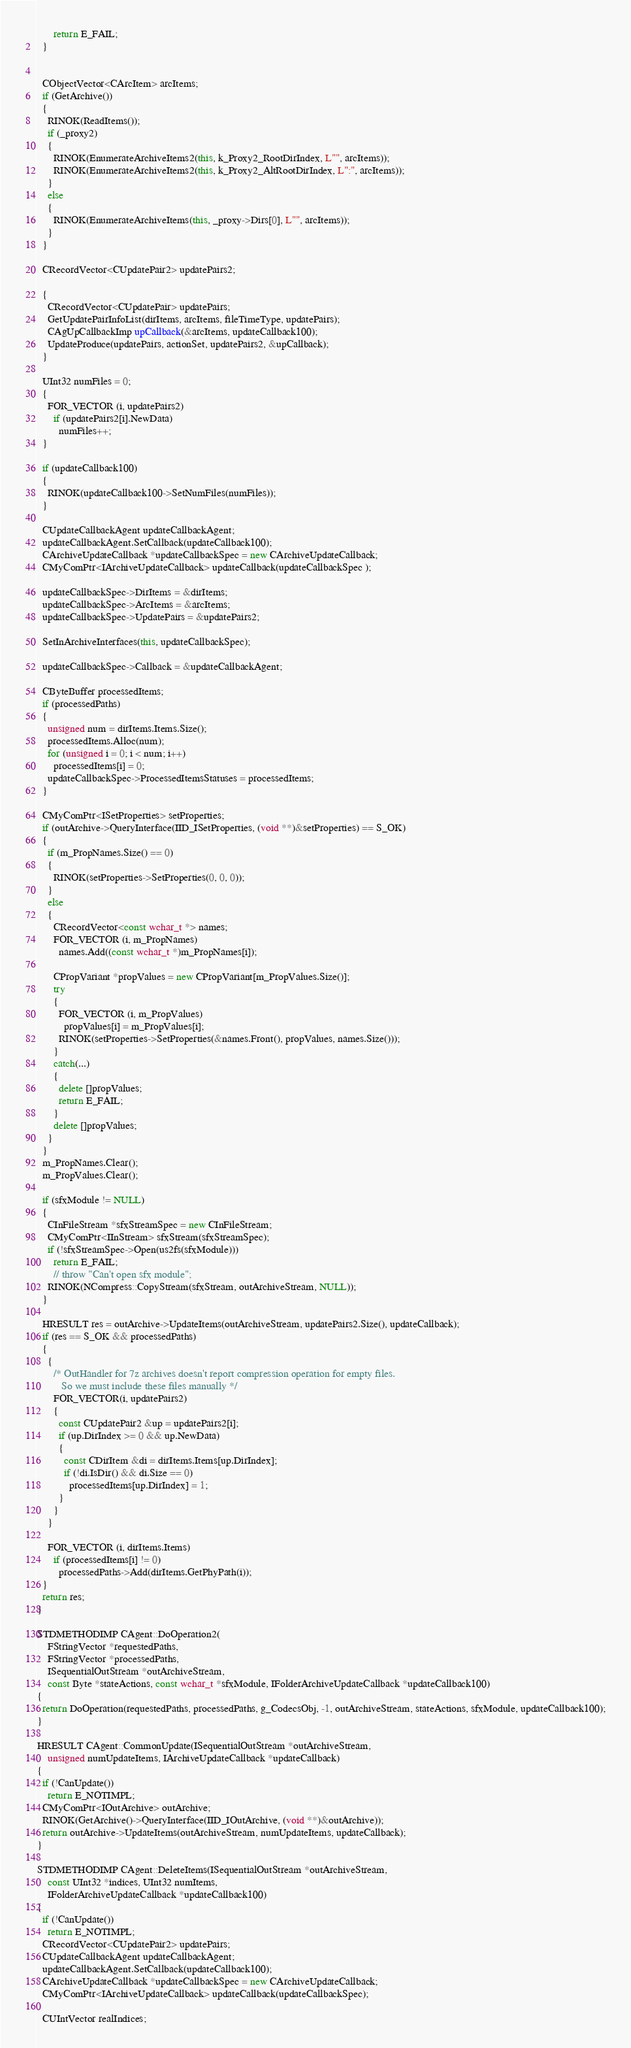<code> <loc_0><loc_0><loc_500><loc_500><_C++_>      return E_FAIL;
  }


  CObjectVector<CArcItem> arcItems;
  if (GetArchive())
  {
    RINOK(ReadItems());
    if (_proxy2)
    {
      RINOK(EnumerateArchiveItems2(this, k_Proxy2_RootDirIndex, L"", arcItems));
      RINOK(EnumerateArchiveItems2(this, k_Proxy2_AltRootDirIndex, L":", arcItems));
    }
    else
    {
      RINOK(EnumerateArchiveItems(this, _proxy->Dirs[0], L"", arcItems));
    }
  }

  CRecordVector<CUpdatePair2> updatePairs2;

  {
    CRecordVector<CUpdatePair> updatePairs;
    GetUpdatePairInfoList(dirItems, arcItems, fileTimeType, updatePairs);
    CAgUpCallbackImp upCallback(&arcItems, updateCallback100);
    UpdateProduce(updatePairs, actionSet, updatePairs2, &upCallback);
  }

  UInt32 numFiles = 0;
  {
    FOR_VECTOR (i, updatePairs2)
      if (updatePairs2[i].NewData)
        numFiles++;
  }
  
  if (updateCallback100)
  {
    RINOK(updateCallback100->SetNumFiles(numFiles));
  }
  
  CUpdateCallbackAgent updateCallbackAgent;
  updateCallbackAgent.SetCallback(updateCallback100);
  CArchiveUpdateCallback *updateCallbackSpec = new CArchiveUpdateCallback;
  CMyComPtr<IArchiveUpdateCallback> updateCallback(updateCallbackSpec );

  updateCallbackSpec->DirItems = &dirItems;
  updateCallbackSpec->ArcItems = &arcItems;
  updateCallbackSpec->UpdatePairs = &updatePairs2;
  
  SetInArchiveInterfaces(this, updateCallbackSpec);
  
  updateCallbackSpec->Callback = &updateCallbackAgent;

  CByteBuffer processedItems;
  if (processedPaths)
  {
    unsigned num = dirItems.Items.Size();
    processedItems.Alloc(num);
    for (unsigned i = 0; i < num; i++)
      processedItems[i] = 0;
    updateCallbackSpec->ProcessedItemsStatuses = processedItems;
  }

  CMyComPtr<ISetProperties> setProperties;
  if (outArchive->QueryInterface(IID_ISetProperties, (void **)&setProperties) == S_OK)
  {
    if (m_PropNames.Size() == 0)
    {
      RINOK(setProperties->SetProperties(0, 0, 0));
    }
    else
    {
      CRecordVector<const wchar_t *> names;
      FOR_VECTOR (i, m_PropNames)
        names.Add((const wchar_t *)m_PropNames[i]);

      CPropVariant *propValues = new CPropVariant[m_PropValues.Size()];
      try
      {
        FOR_VECTOR (i, m_PropValues)
          propValues[i] = m_PropValues[i];
        RINOK(setProperties->SetProperties(&names.Front(), propValues, names.Size()));
      }
      catch(...)
      {
        delete []propValues;
        return E_FAIL;
      }
      delete []propValues;
    }
  }
  m_PropNames.Clear();
  m_PropValues.Clear();

  if (sfxModule != NULL)
  {
    CInFileStream *sfxStreamSpec = new CInFileStream;
    CMyComPtr<IInStream> sfxStream(sfxStreamSpec);
    if (!sfxStreamSpec->Open(us2fs(sfxModule)))
      return E_FAIL;
      // throw "Can't open sfx module";
    RINOK(NCompress::CopyStream(sfxStream, outArchiveStream, NULL));
  }

  HRESULT res = outArchive->UpdateItems(outArchiveStream, updatePairs2.Size(), updateCallback);
  if (res == S_OK && processedPaths)
  {
    {
      /* OutHandler for 7z archives doesn't report compression operation for empty files.
         So we must include these files manually */
      FOR_VECTOR(i, updatePairs2)
      {
        const CUpdatePair2 &up = updatePairs2[i];
        if (up.DirIndex >= 0 && up.NewData)
        {
          const CDirItem &di = dirItems.Items[up.DirIndex];
          if (!di.IsDir() && di.Size == 0)
            processedItems[up.DirIndex] = 1;
        }
      }
    }

    FOR_VECTOR (i, dirItems.Items)
      if (processedItems[i] != 0)
        processedPaths->Add(dirItems.GetPhyPath(i));
  }
  return res;
}

STDMETHODIMP CAgent::DoOperation2(
    FStringVector *requestedPaths,
    FStringVector *processedPaths,
    ISequentialOutStream *outArchiveStream,
    const Byte *stateActions, const wchar_t *sfxModule, IFolderArchiveUpdateCallback *updateCallback100)
{
  return DoOperation(requestedPaths, processedPaths, g_CodecsObj, -1, outArchiveStream, stateActions, sfxModule, updateCallback100);
}

HRESULT CAgent::CommonUpdate(ISequentialOutStream *outArchiveStream,
    unsigned numUpdateItems, IArchiveUpdateCallback *updateCallback)
{
  if (!CanUpdate())
    return E_NOTIMPL;
  CMyComPtr<IOutArchive> outArchive;
  RINOK(GetArchive()->QueryInterface(IID_IOutArchive, (void **)&outArchive));
  return outArchive->UpdateItems(outArchiveStream, numUpdateItems, updateCallback);
}

STDMETHODIMP CAgent::DeleteItems(ISequentialOutStream *outArchiveStream,
    const UInt32 *indices, UInt32 numItems,
    IFolderArchiveUpdateCallback *updateCallback100)
{
  if (!CanUpdate())
    return E_NOTIMPL;
  CRecordVector<CUpdatePair2> updatePairs;
  CUpdateCallbackAgent updateCallbackAgent;
  updateCallbackAgent.SetCallback(updateCallback100);
  CArchiveUpdateCallback *updateCallbackSpec = new CArchiveUpdateCallback;
  CMyComPtr<IArchiveUpdateCallback> updateCallback(updateCallbackSpec);
  
  CUIntVector realIndices;</code> 